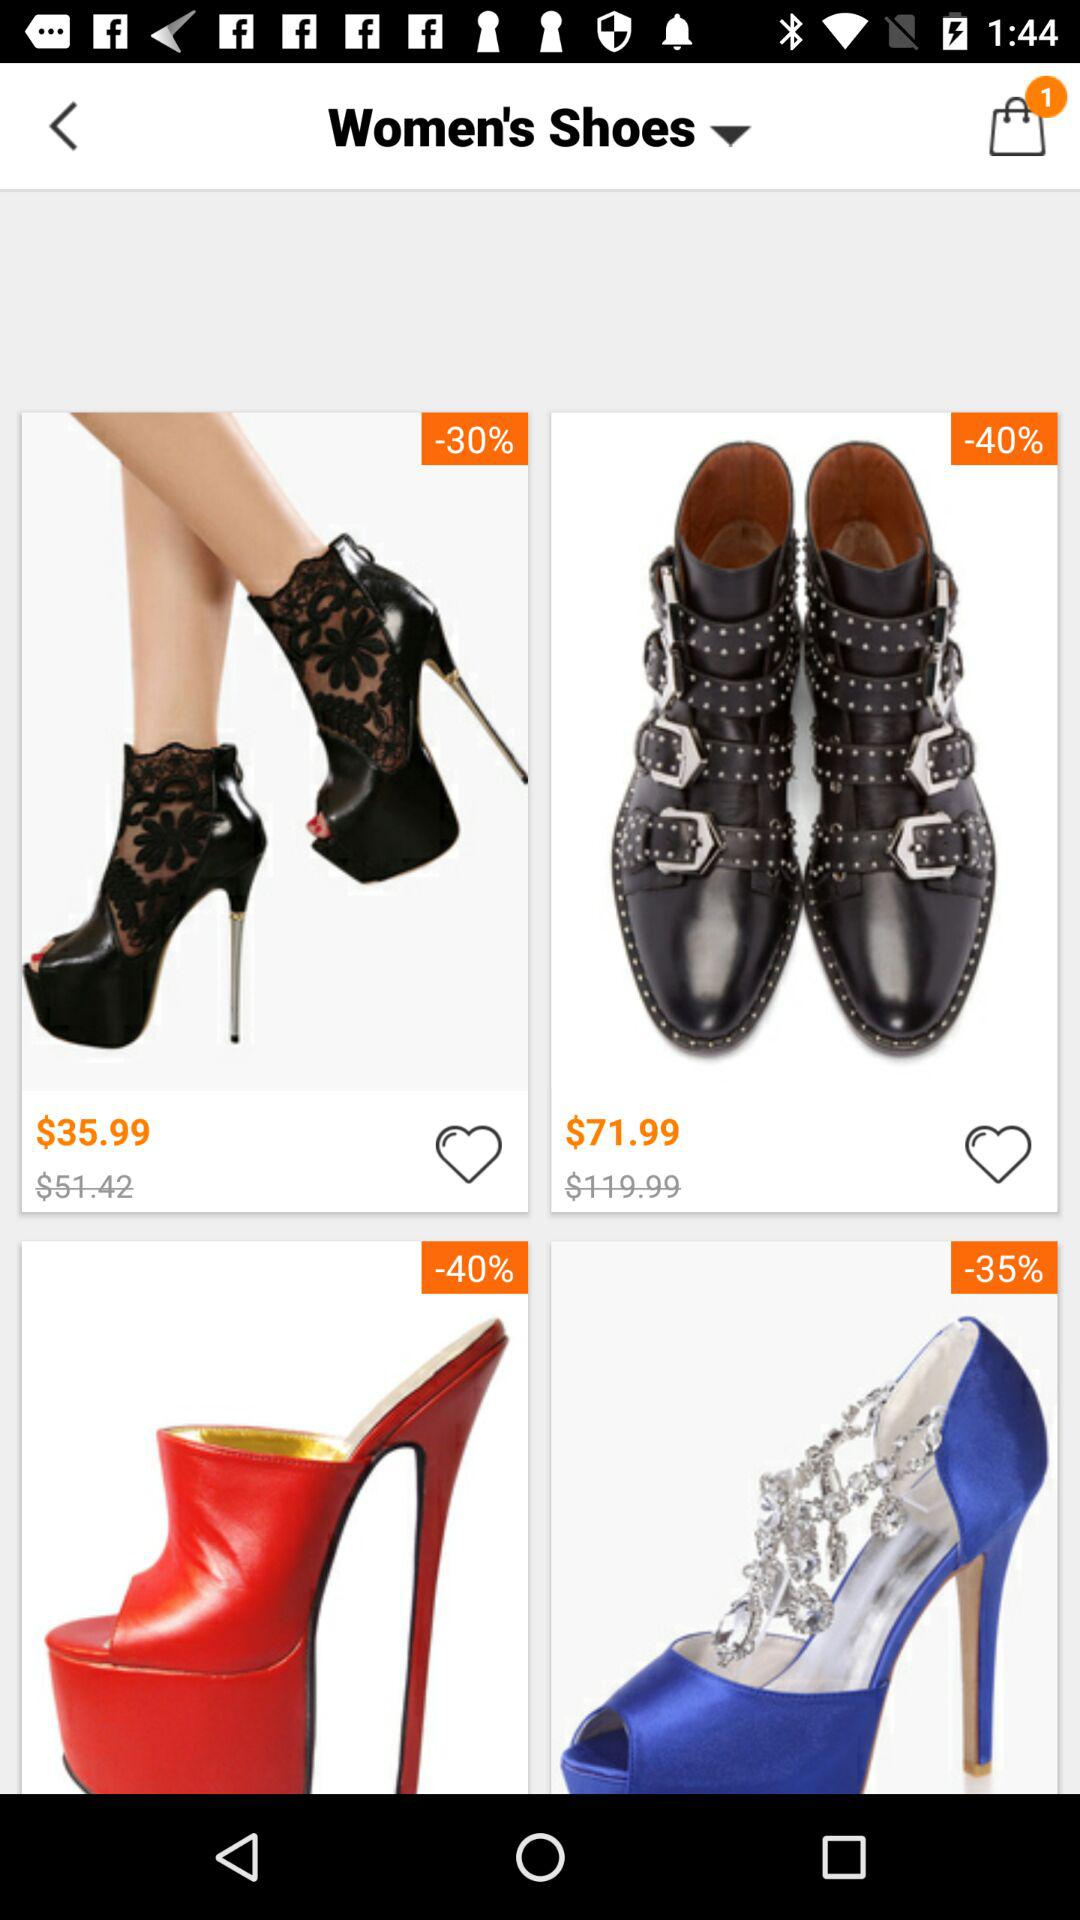Which option has been chosen? The option "Women's Shoes" has been chosen. 